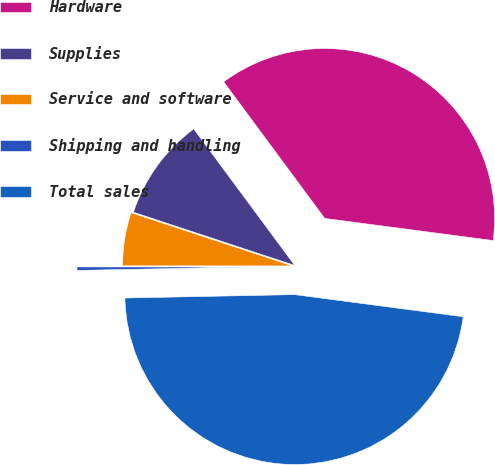Convert chart to OTSL. <chart><loc_0><loc_0><loc_500><loc_500><pie_chart><fcel>Hardware<fcel>Supplies<fcel>Service and software<fcel>Shipping and handling<fcel>Total sales<nl><fcel>37.22%<fcel>9.79%<fcel>5.06%<fcel>0.33%<fcel>47.6%<nl></chart> 